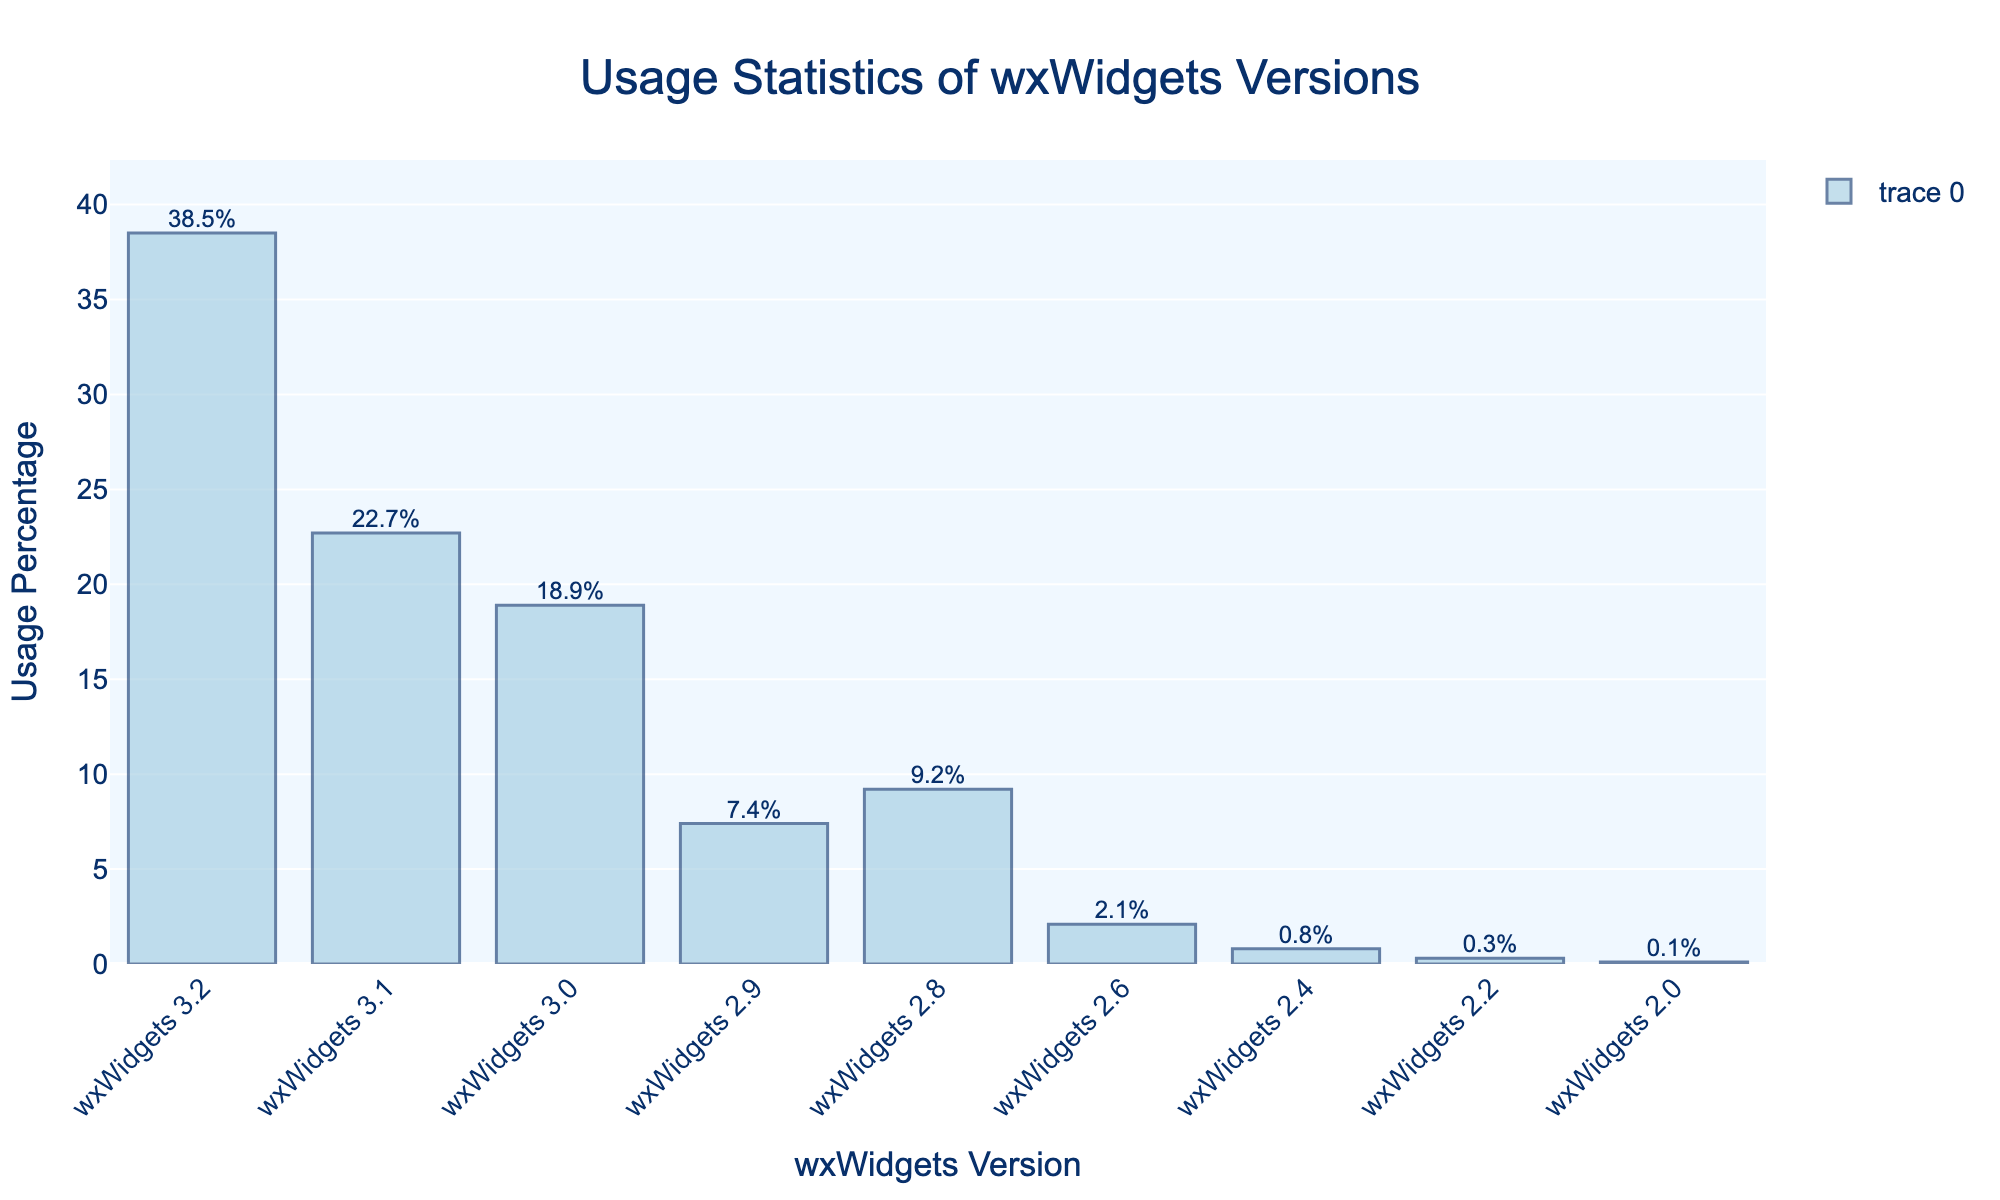How many versions of wxWidgets have more than 20% usage? To determine this, identify the versions with a usage percentage above 20%. From the figure, wxWidgets 3.2 and wxWidgets 3.1 have usage percentages of 38.5% and 22.7%, respectively.
Answer: 2 Which wxWidgets version has the highest usage percentage? Locate the bar that is the tallest, which represents the highest usage percentage. The bar for wxWidgets 3.2 is the tallest at 38.5%.
Answer: wxWidgets 3.2 What is the combined usage percentage of wxWidgets versions 3.0 and 3.1? Add the percentages of wxWidgets 3.0 and 3.1. The usage percentages are 18.9% and 22.7%, respectively, so the combined usage is 18.9% + 22.7% = 41.6%.
Answer: 41.6% How much more popular is wxWidgets 3.2 compared to wxWidgets 2.8? Subtract the usage percentage of wxWidgets 2.8 from that of wxWidgets 3.2. WxWidgets 3.2 has a percentage of 38.5% and wxWidgets 2.8 has 9.2%, so the difference is 38.5% - 9.2% = 29.3%.
Answer: 29.3% What is the least used version of wxWidgets? Find the bar with the shortest height representing the lowest percentage. The shortest bar is for wxWidgets 2.0 with a usage percentage of 0.1%.
Answer: wxWidgets 2.0 If wxWidgets 2.6 had its percentage doubled, would it surpass wxWidgets 2.8 in usage? First, calculate double the percentage of wxWidgets 2.6: 2.1% * 2 = 4.2%. Compare this with the usage of wxWidgets 2.8, which is 9.2%. Since 4.2% is less than 9.2%, it would not surpass.
Answer: No Which versions have a usage percentage between 5% and 10%? Identify the versions with a percentage within the given range. WxWidgets 2.9 and wxWidgets 2.8 have usage percentages of 7.4% and 9.2%, respectively.
Answer: wxWidgets 2.9, wxWidgets 2.8 What is the average usage percentage of all versions listed? Sum all the usage percentages and divide by the number of versions. Total percentage = 38.5 + 22.7 + 18.9 + 7.4 + 9.2 + 2.1 + 0.8 + 0.3 + 0.1 = 100%. Number of versions = 9. Average = 100% / 9 ≈ 11.1%.
Answer: 11.1% How many versions have single-digit percentage usage? Count the bars with usage percentages less than 10%. These are wxWidgets 2.9 (7.4%), wxWidgets 2.8 (9.2%), wxWidgets 2.6 (2.1%), wxWidgets 2.4 (0.8%), wxWidgets 2.2 (0.3%), and wxWidgets 2.0 (0.1%). There are 6 such versions.
Answer: 6 